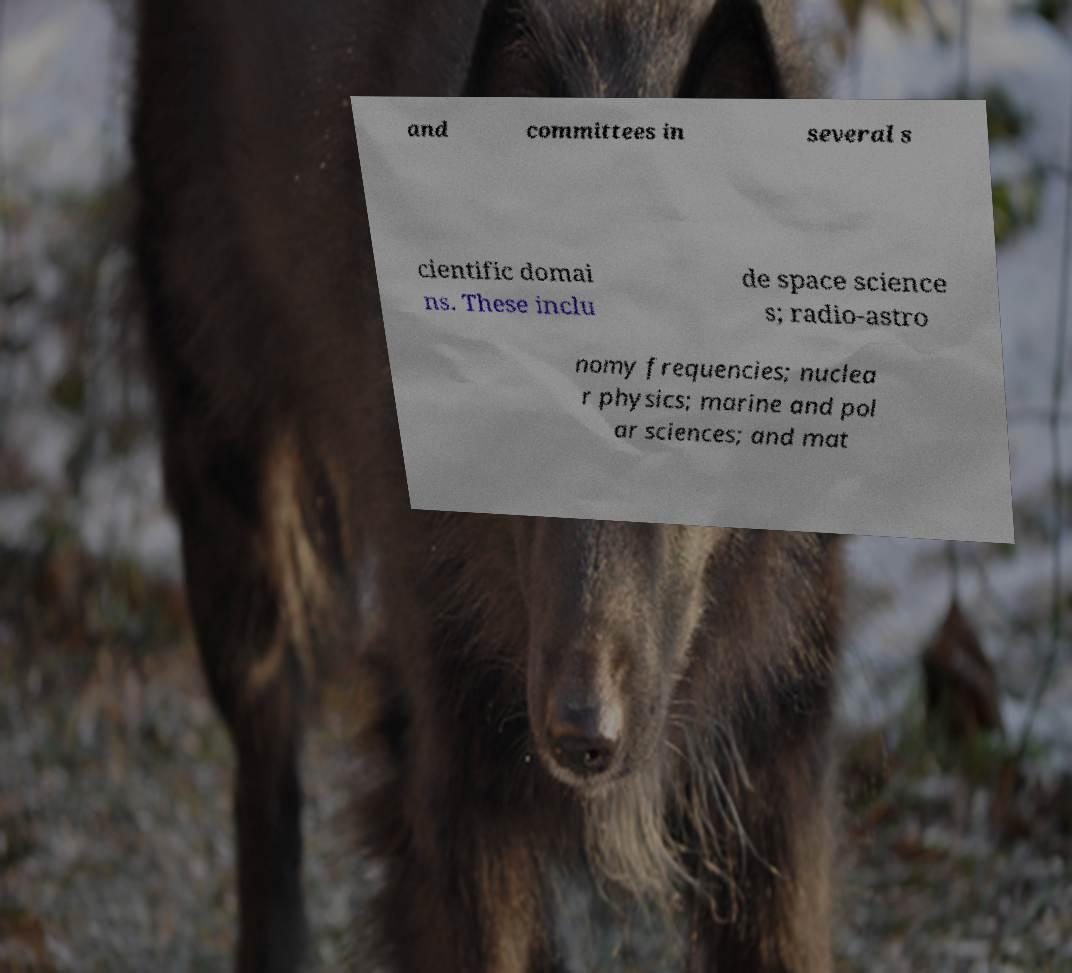What messages or text are displayed in this image? I need them in a readable, typed format. and committees in several s cientific domai ns. These inclu de space science s; radio-astro nomy frequencies; nuclea r physics; marine and pol ar sciences; and mat 